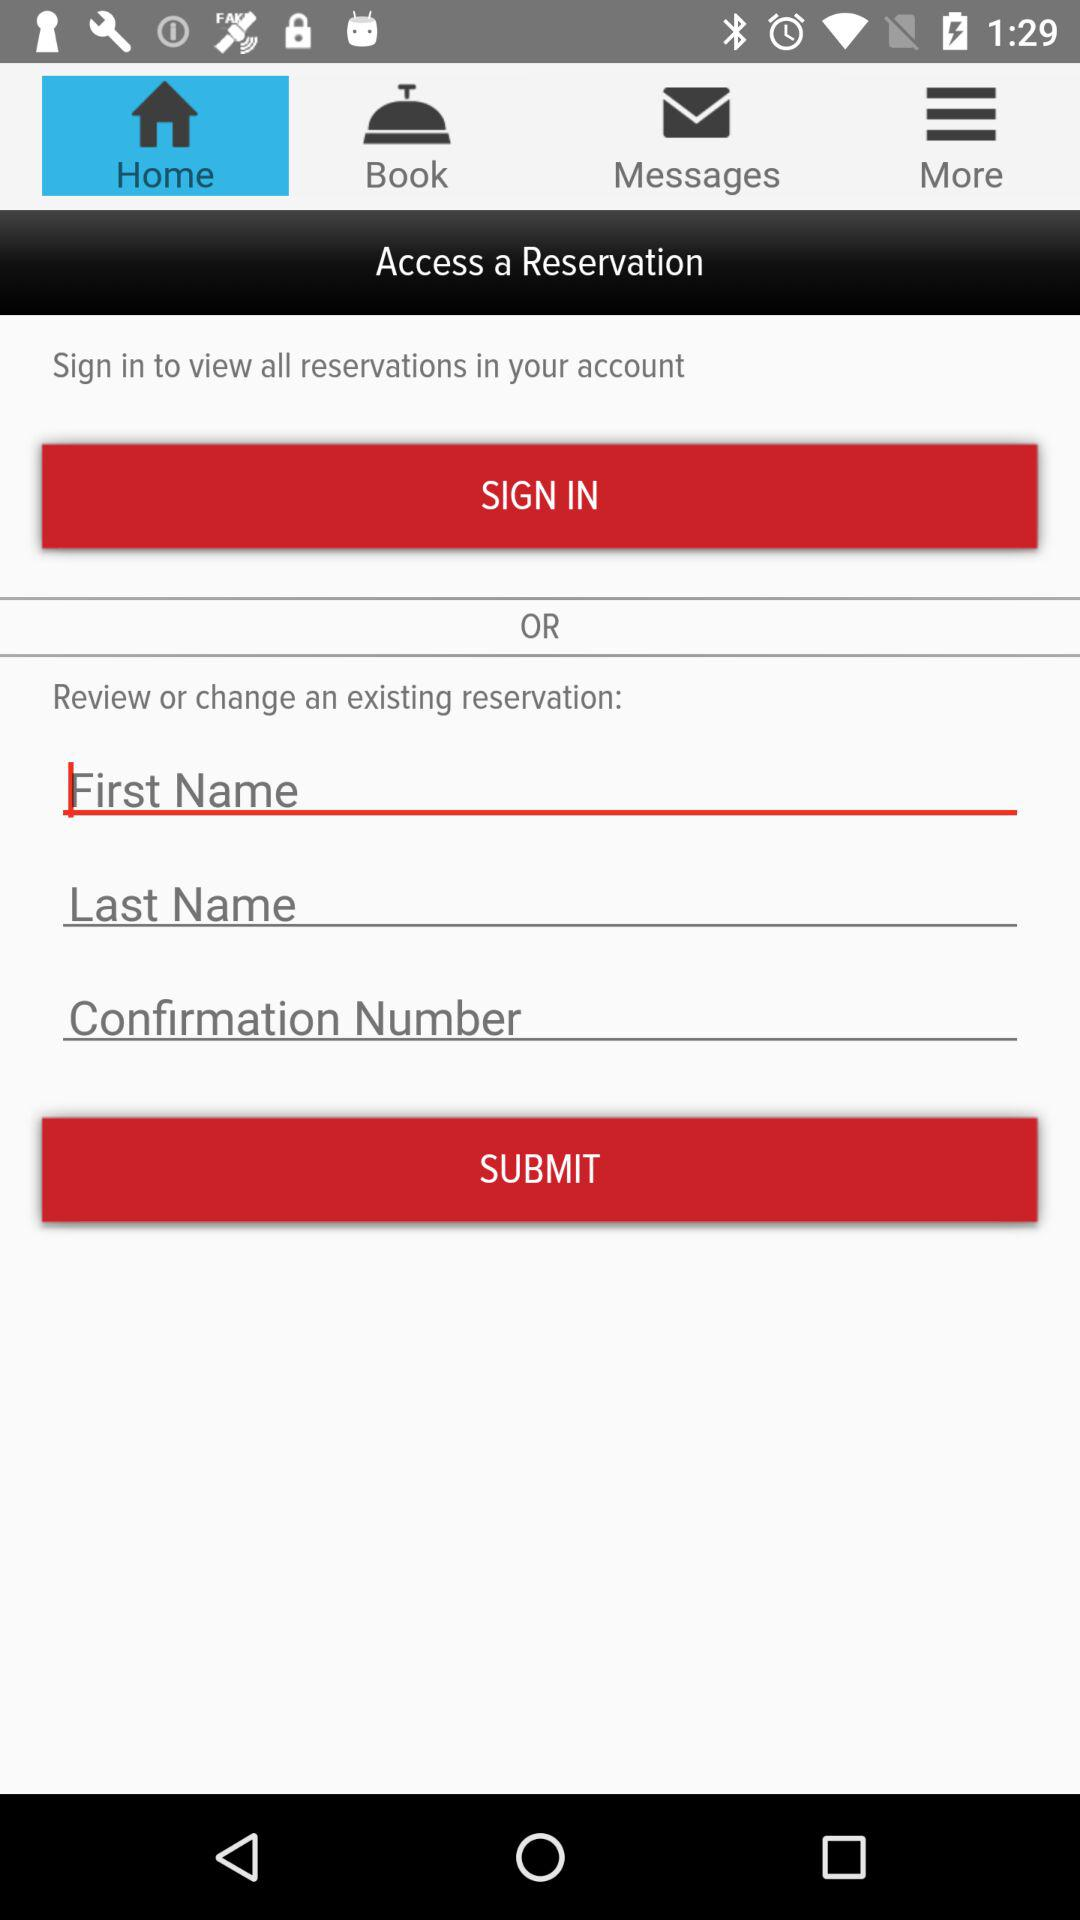How many text inputs are required to access a reservation?
Answer the question using a single word or phrase. 3 